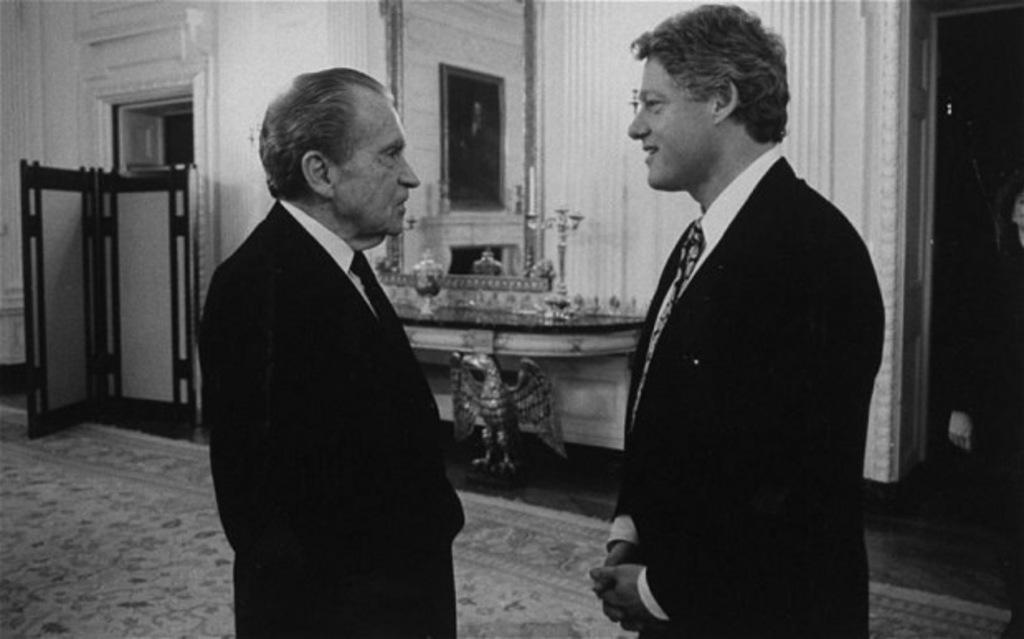What is the color scheme of the image? The image is black and white. How many people are in the image? There are two persons standing on a mat. What can be seen in the background of the image? There is a table and a wall in the background of the image. What feature of the wall is mentioned in the facts? There are doors in the wall. Can you see a ladybug crawling on the mat in the image? There is no ladybug present in the image. What type of egg is visible on the table in the image? There are no eggs visible on the table in the image. 